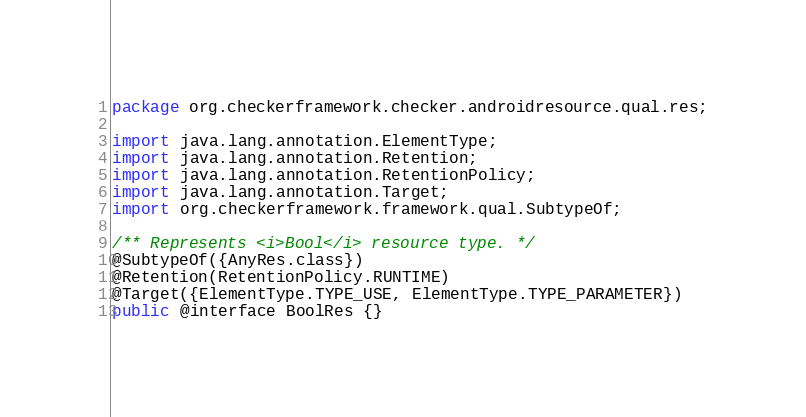Convert code to text. <code><loc_0><loc_0><loc_500><loc_500><_Java_>package org.checkerframework.checker.androidresource.qual.res;

import java.lang.annotation.ElementType;
import java.lang.annotation.Retention;
import java.lang.annotation.RetentionPolicy;
import java.lang.annotation.Target;
import org.checkerframework.framework.qual.SubtypeOf;

/** Represents <i>Bool</i> resource type. */
@SubtypeOf({AnyRes.class})
@Retention(RetentionPolicy.RUNTIME)
@Target({ElementType.TYPE_USE, ElementType.TYPE_PARAMETER})
public @interface BoolRes {}
</code> 